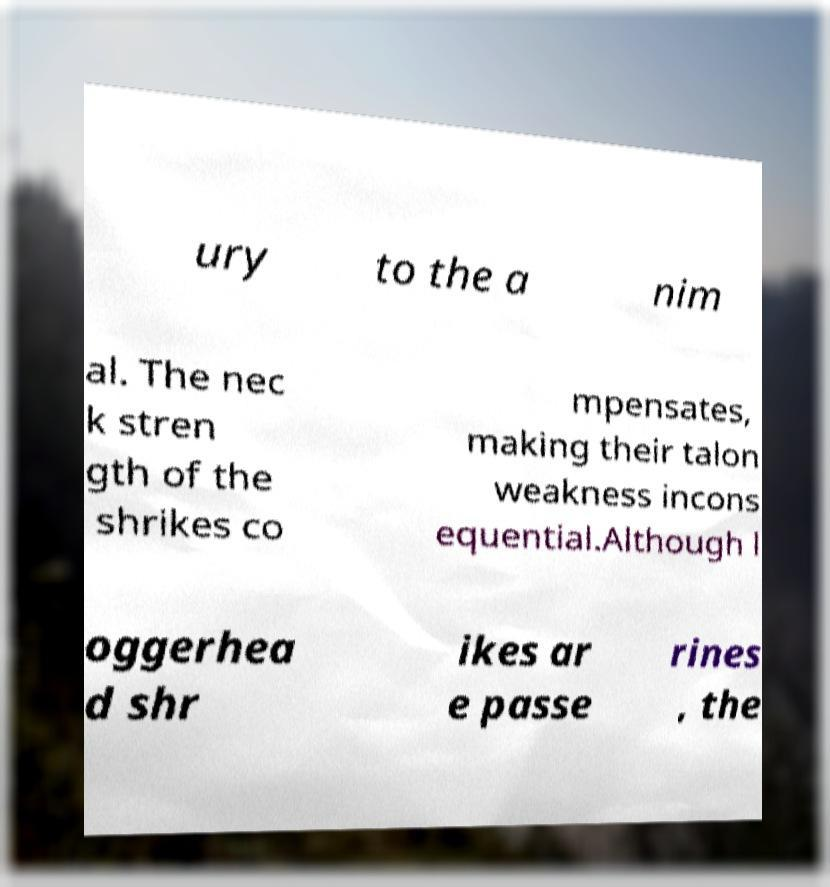What messages or text are displayed in this image? I need them in a readable, typed format. ury to the a nim al. The nec k stren gth of the shrikes co mpensates, making their talon weakness incons equential.Although l oggerhea d shr ikes ar e passe rines , the 